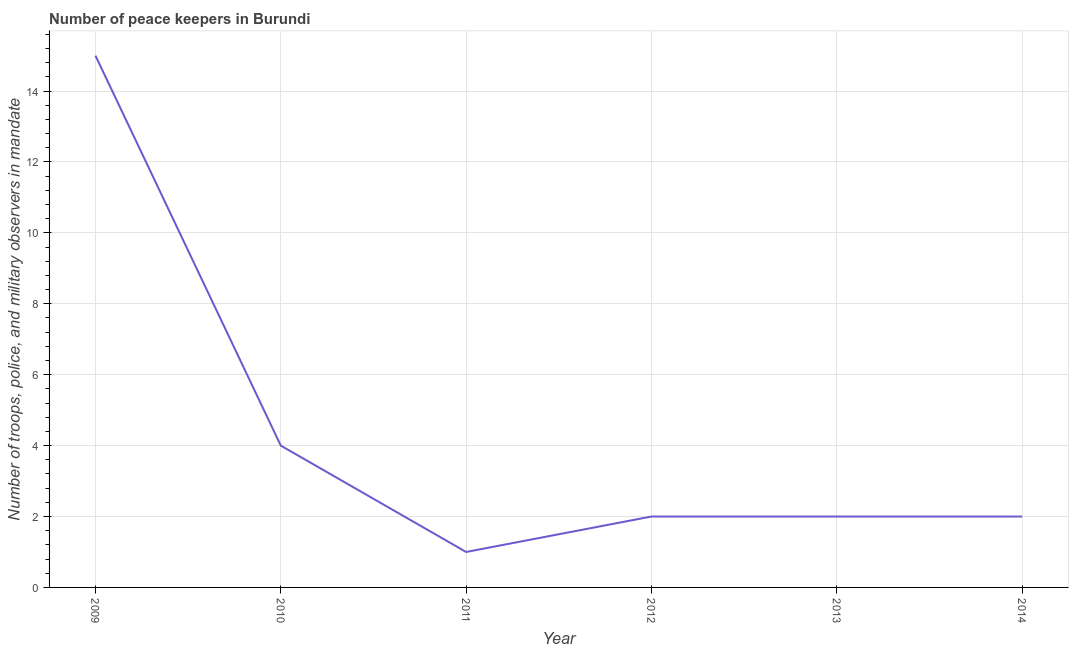What is the number of peace keepers in 2009?
Your answer should be very brief. 15. Across all years, what is the maximum number of peace keepers?
Keep it short and to the point. 15. Across all years, what is the minimum number of peace keepers?
Your answer should be very brief. 1. In which year was the number of peace keepers minimum?
Offer a very short reply. 2011. What is the sum of the number of peace keepers?
Your answer should be compact. 26. What is the difference between the number of peace keepers in 2011 and 2012?
Provide a succinct answer. -1. What is the average number of peace keepers per year?
Ensure brevity in your answer.  4.33. In how many years, is the number of peace keepers greater than 9.6 ?
Provide a succinct answer. 1. Do a majority of the years between 2013 and 2010 (inclusive) have number of peace keepers greater than 10.4 ?
Your answer should be compact. Yes. What is the ratio of the number of peace keepers in 2009 to that in 2011?
Make the answer very short. 15. What is the difference between the highest and the second highest number of peace keepers?
Give a very brief answer. 11. What is the difference between the highest and the lowest number of peace keepers?
Provide a succinct answer. 14. How many lines are there?
Keep it short and to the point. 1. How many years are there in the graph?
Provide a short and direct response. 6. What is the difference between two consecutive major ticks on the Y-axis?
Provide a succinct answer. 2. What is the title of the graph?
Make the answer very short. Number of peace keepers in Burundi. What is the label or title of the X-axis?
Offer a terse response. Year. What is the label or title of the Y-axis?
Your response must be concise. Number of troops, police, and military observers in mandate. What is the Number of troops, police, and military observers in mandate in 2011?
Your answer should be compact. 1. What is the Number of troops, police, and military observers in mandate in 2012?
Offer a terse response. 2. What is the difference between the Number of troops, police, and military observers in mandate in 2009 and 2012?
Make the answer very short. 13. What is the difference between the Number of troops, police, and military observers in mandate in 2009 and 2013?
Provide a short and direct response. 13. What is the difference between the Number of troops, police, and military observers in mandate in 2010 and 2011?
Provide a short and direct response. 3. What is the difference between the Number of troops, police, and military observers in mandate in 2010 and 2012?
Your answer should be very brief. 2. What is the difference between the Number of troops, police, and military observers in mandate in 2010 and 2013?
Provide a succinct answer. 2. What is the difference between the Number of troops, police, and military observers in mandate in 2011 and 2012?
Ensure brevity in your answer.  -1. What is the difference between the Number of troops, police, and military observers in mandate in 2011 and 2013?
Ensure brevity in your answer.  -1. What is the difference between the Number of troops, police, and military observers in mandate in 2011 and 2014?
Offer a very short reply. -1. What is the difference between the Number of troops, police, and military observers in mandate in 2012 and 2013?
Make the answer very short. 0. What is the difference between the Number of troops, police, and military observers in mandate in 2012 and 2014?
Your answer should be very brief. 0. What is the ratio of the Number of troops, police, and military observers in mandate in 2009 to that in 2010?
Give a very brief answer. 3.75. What is the ratio of the Number of troops, police, and military observers in mandate in 2009 to that in 2013?
Provide a short and direct response. 7.5. What is the ratio of the Number of troops, police, and military observers in mandate in 2010 to that in 2012?
Ensure brevity in your answer.  2. What is the ratio of the Number of troops, police, and military observers in mandate in 2011 to that in 2012?
Make the answer very short. 0.5. What is the ratio of the Number of troops, police, and military observers in mandate in 2011 to that in 2014?
Provide a succinct answer. 0.5. What is the ratio of the Number of troops, police, and military observers in mandate in 2012 to that in 2013?
Ensure brevity in your answer.  1. What is the ratio of the Number of troops, police, and military observers in mandate in 2013 to that in 2014?
Your answer should be very brief. 1. 